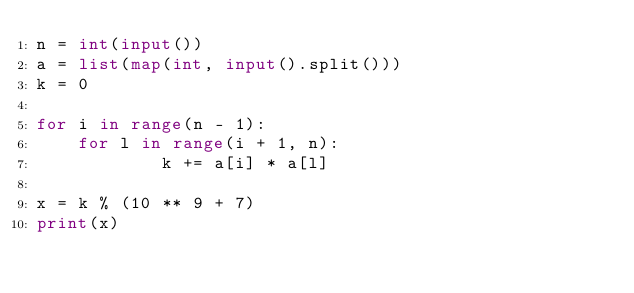Convert code to text. <code><loc_0><loc_0><loc_500><loc_500><_Python_>n = int(input())
a = list(map(int, input().split()))
k = 0

for i in range(n - 1):
    for l in range(i + 1, n):
            k += a[i] * a[l]

x = k % (10 ** 9 + 7)
print(x)
</code> 